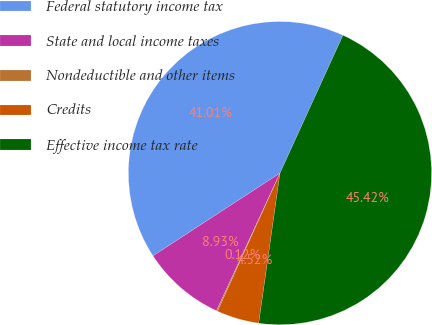Convert chart to OTSL. <chart><loc_0><loc_0><loc_500><loc_500><pie_chart><fcel>Federal statutory income tax<fcel>State and local income taxes<fcel>Nondeductible and other items<fcel>Credits<fcel>Effective income tax rate<nl><fcel>41.01%<fcel>8.93%<fcel>0.12%<fcel>4.52%<fcel>45.42%<nl></chart> 